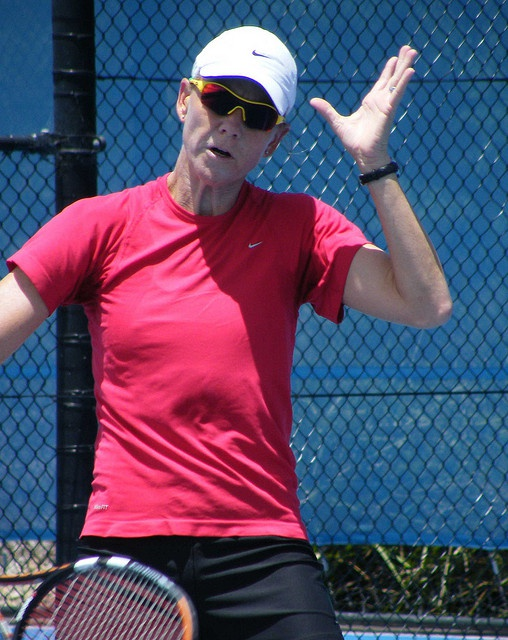Describe the objects in this image and their specific colors. I can see people in darkblue, maroon, violet, black, and brown tones and tennis racket in darkblue, gray, purple, darkgray, and black tones in this image. 